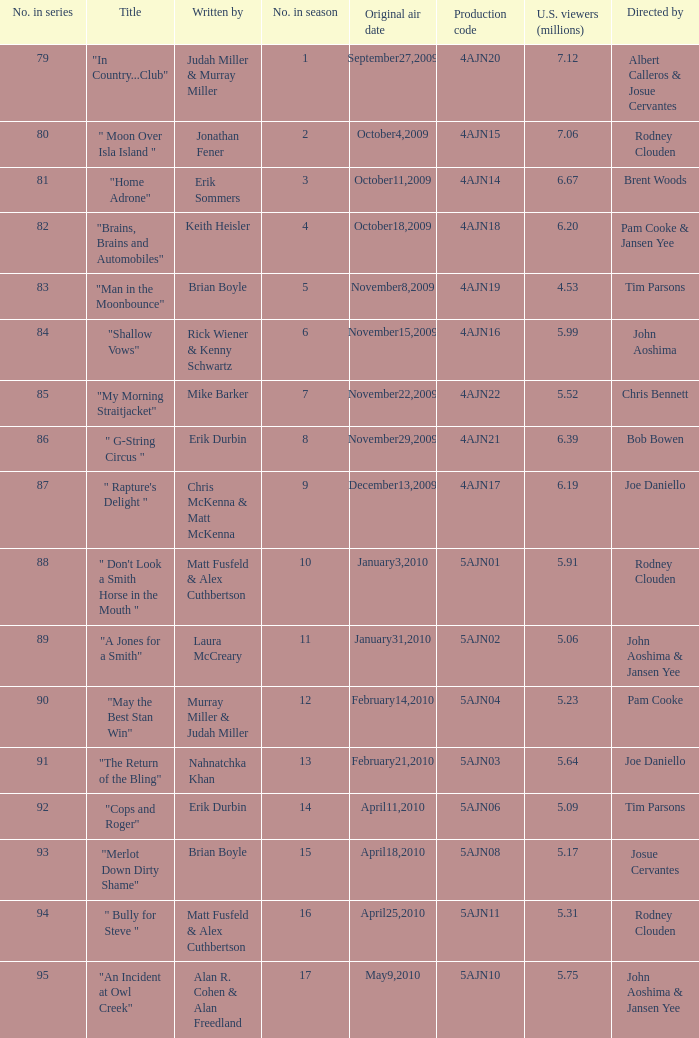Name who wrote the episode directed by  pam cooke & jansen yee Keith Heisler. 